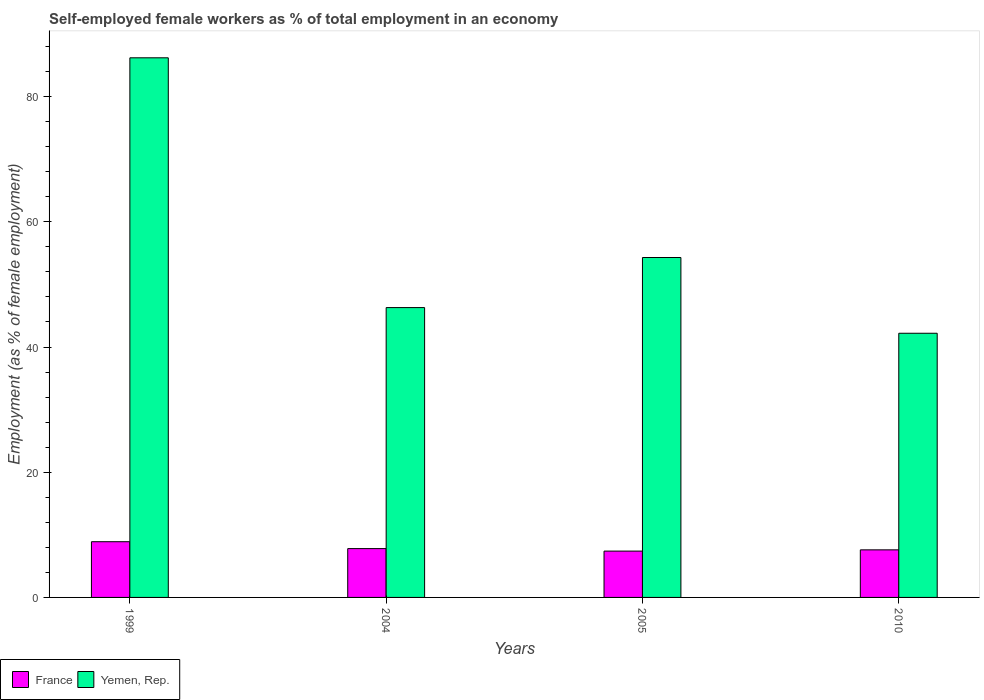How many groups of bars are there?
Provide a short and direct response. 4. Are the number of bars per tick equal to the number of legend labels?
Give a very brief answer. Yes. Are the number of bars on each tick of the X-axis equal?
Make the answer very short. Yes. How many bars are there on the 3rd tick from the left?
Your response must be concise. 2. In how many cases, is the number of bars for a given year not equal to the number of legend labels?
Make the answer very short. 0. What is the percentage of self-employed female workers in Yemen, Rep. in 2010?
Your answer should be very brief. 42.2. Across all years, what is the maximum percentage of self-employed female workers in France?
Keep it short and to the point. 8.9. Across all years, what is the minimum percentage of self-employed female workers in Yemen, Rep.?
Offer a very short reply. 42.2. In which year was the percentage of self-employed female workers in France minimum?
Offer a terse response. 2005. What is the total percentage of self-employed female workers in Yemen, Rep. in the graph?
Your answer should be compact. 229. What is the difference between the percentage of self-employed female workers in Yemen, Rep. in 1999 and that in 2004?
Your answer should be compact. 39.9. What is the difference between the percentage of self-employed female workers in Yemen, Rep. in 2005 and the percentage of self-employed female workers in France in 2004?
Provide a short and direct response. 46.5. What is the average percentage of self-employed female workers in France per year?
Your answer should be very brief. 7.92. In the year 2010, what is the difference between the percentage of self-employed female workers in France and percentage of self-employed female workers in Yemen, Rep.?
Your answer should be compact. -34.6. What is the ratio of the percentage of self-employed female workers in Yemen, Rep. in 1999 to that in 2010?
Offer a very short reply. 2.04. Is the difference between the percentage of self-employed female workers in France in 1999 and 2005 greater than the difference between the percentage of self-employed female workers in Yemen, Rep. in 1999 and 2005?
Provide a succinct answer. No. What is the difference between the highest and the second highest percentage of self-employed female workers in France?
Give a very brief answer. 1.1. What is the difference between the highest and the lowest percentage of self-employed female workers in Yemen, Rep.?
Your answer should be compact. 44. What does the 1st bar from the left in 1999 represents?
Provide a short and direct response. France. What does the 2nd bar from the right in 2005 represents?
Provide a short and direct response. France. How many bars are there?
Your response must be concise. 8. Are the values on the major ticks of Y-axis written in scientific E-notation?
Give a very brief answer. No. Where does the legend appear in the graph?
Your answer should be very brief. Bottom left. What is the title of the graph?
Provide a short and direct response. Self-employed female workers as % of total employment in an economy. Does "Austria" appear as one of the legend labels in the graph?
Your answer should be very brief. No. What is the label or title of the Y-axis?
Give a very brief answer. Employment (as % of female employment). What is the Employment (as % of female employment) of France in 1999?
Make the answer very short. 8.9. What is the Employment (as % of female employment) of Yemen, Rep. in 1999?
Your answer should be very brief. 86.2. What is the Employment (as % of female employment) of France in 2004?
Provide a short and direct response. 7.8. What is the Employment (as % of female employment) of Yemen, Rep. in 2004?
Provide a short and direct response. 46.3. What is the Employment (as % of female employment) of France in 2005?
Offer a very short reply. 7.4. What is the Employment (as % of female employment) in Yemen, Rep. in 2005?
Keep it short and to the point. 54.3. What is the Employment (as % of female employment) in France in 2010?
Provide a short and direct response. 7.6. What is the Employment (as % of female employment) of Yemen, Rep. in 2010?
Make the answer very short. 42.2. Across all years, what is the maximum Employment (as % of female employment) of France?
Ensure brevity in your answer.  8.9. Across all years, what is the maximum Employment (as % of female employment) of Yemen, Rep.?
Offer a very short reply. 86.2. Across all years, what is the minimum Employment (as % of female employment) of France?
Provide a short and direct response. 7.4. Across all years, what is the minimum Employment (as % of female employment) of Yemen, Rep.?
Offer a terse response. 42.2. What is the total Employment (as % of female employment) in France in the graph?
Offer a very short reply. 31.7. What is the total Employment (as % of female employment) of Yemen, Rep. in the graph?
Provide a succinct answer. 229. What is the difference between the Employment (as % of female employment) of France in 1999 and that in 2004?
Ensure brevity in your answer.  1.1. What is the difference between the Employment (as % of female employment) of Yemen, Rep. in 1999 and that in 2004?
Your response must be concise. 39.9. What is the difference between the Employment (as % of female employment) of France in 1999 and that in 2005?
Your answer should be compact. 1.5. What is the difference between the Employment (as % of female employment) of Yemen, Rep. in 1999 and that in 2005?
Your answer should be very brief. 31.9. What is the difference between the Employment (as % of female employment) in France in 1999 and that in 2010?
Offer a very short reply. 1.3. What is the difference between the Employment (as % of female employment) of France in 2004 and that in 2010?
Offer a terse response. 0.2. What is the difference between the Employment (as % of female employment) in France in 2005 and that in 2010?
Offer a very short reply. -0.2. What is the difference between the Employment (as % of female employment) of Yemen, Rep. in 2005 and that in 2010?
Provide a short and direct response. 12.1. What is the difference between the Employment (as % of female employment) in France in 1999 and the Employment (as % of female employment) in Yemen, Rep. in 2004?
Provide a short and direct response. -37.4. What is the difference between the Employment (as % of female employment) of France in 1999 and the Employment (as % of female employment) of Yemen, Rep. in 2005?
Make the answer very short. -45.4. What is the difference between the Employment (as % of female employment) in France in 1999 and the Employment (as % of female employment) in Yemen, Rep. in 2010?
Your answer should be compact. -33.3. What is the difference between the Employment (as % of female employment) in France in 2004 and the Employment (as % of female employment) in Yemen, Rep. in 2005?
Keep it short and to the point. -46.5. What is the difference between the Employment (as % of female employment) in France in 2004 and the Employment (as % of female employment) in Yemen, Rep. in 2010?
Provide a short and direct response. -34.4. What is the difference between the Employment (as % of female employment) in France in 2005 and the Employment (as % of female employment) in Yemen, Rep. in 2010?
Make the answer very short. -34.8. What is the average Employment (as % of female employment) in France per year?
Give a very brief answer. 7.92. What is the average Employment (as % of female employment) of Yemen, Rep. per year?
Give a very brief answer. 57.25. In the year 1999, what is the difference between the Employment (as % of female employment) of France and Employment (as % of female employment) of Yemen, Rep.?
Provide a short and direct response. -77.3. In the year 2004, what is the difference between the Employment (as % of female employment) of France and Employment (as % of female employment) of Yemen, Rep.?
Your response must be concise. -38.5. In the year 2005, what is the difference between the Employment (as % of female employment) of France and Employment (as % of female employment) of Yemen, Rep.?
Offer a very short reply. -46.9. In the year 2010, what is the difference between the Employment (as % of female employment) of France and Employment (as % of female employment) of Yemen, Rep.?
Offer a terse response. -34.6. What is the ratio of the Employment (as % of female employment) in France in 1999 to that in 2004?
Offer a terse response. 1.14. What is the ratio of the Employment (as % of female employment) in Yemen, Rep. in 1999 to that in 2004?
Offer a very short reply. 1.86. What is the ratio of the Employment (as % of female employment) of France in 1999 to that in 2005?
Your answer should be compact. 1.2. What is the ratio of the Employment (as % of female employment) in Yemen, Rep. in 1999 to that in 2005?
Provide a succinct answer. 1.59. What is the ratio of the Employment (as % of female employment) of France in 1999 to that in 2010?
Offer a terse response. 1.17. What is the ratio of the Employment (as % of female employment) in Yemen, Rep. in 1999 to that in 2010?
Your answer should be compact. 2.04. What is the ratio of the Employment (as % of female employment) of France in 2004 to that in 2005?
Make the answer very short. 1.05. What is the ratio of the Employment (as % of female employment) in Yemen, Rep. in 2004 to that in 2005?
Give a very brief answer. 0.85. What is the ratio of the Employment (as % of female employment) in France in 2004 to that in 2010?
Offer a very short reply. 1.03. What is the ratio of the Employment (as % of female employment) of Yemen, Rep. in 2004 to that in 2010?
Provide a short and direct response. 1.1. What is the ratio of the Employment (as % of female employment) of France in 2005 to that in 2010?
Offer a very short reply. 0.97. What is the ratio of the Employment (as % of female employment) of Yemen, Rep. in 2005 to that in 2010?
Your answer should be very brief. 1.29. What is the difference between the highest and the second highest Employment (as % of female employment) of Yemen, Rep.?
Your answer should be very brief. 31.9. What is the difference between the highest and the lowest Employment (as % of female employment) of France?
Your answer should be very brief. 1.5. What is the difference between the highest and the lowest Employment (as % of female employment) in Yemen, Rep.?
Make the answer very short. 44. 